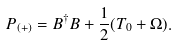Convert formula to latex. <formula><loc_0><loc_0><loc_500><loc_500>P _ { ( + ) } = B ^ { \dagger } B + \frac { 1 } { 2 } ( T _ { 0 } + \Omega ) .</formula> 